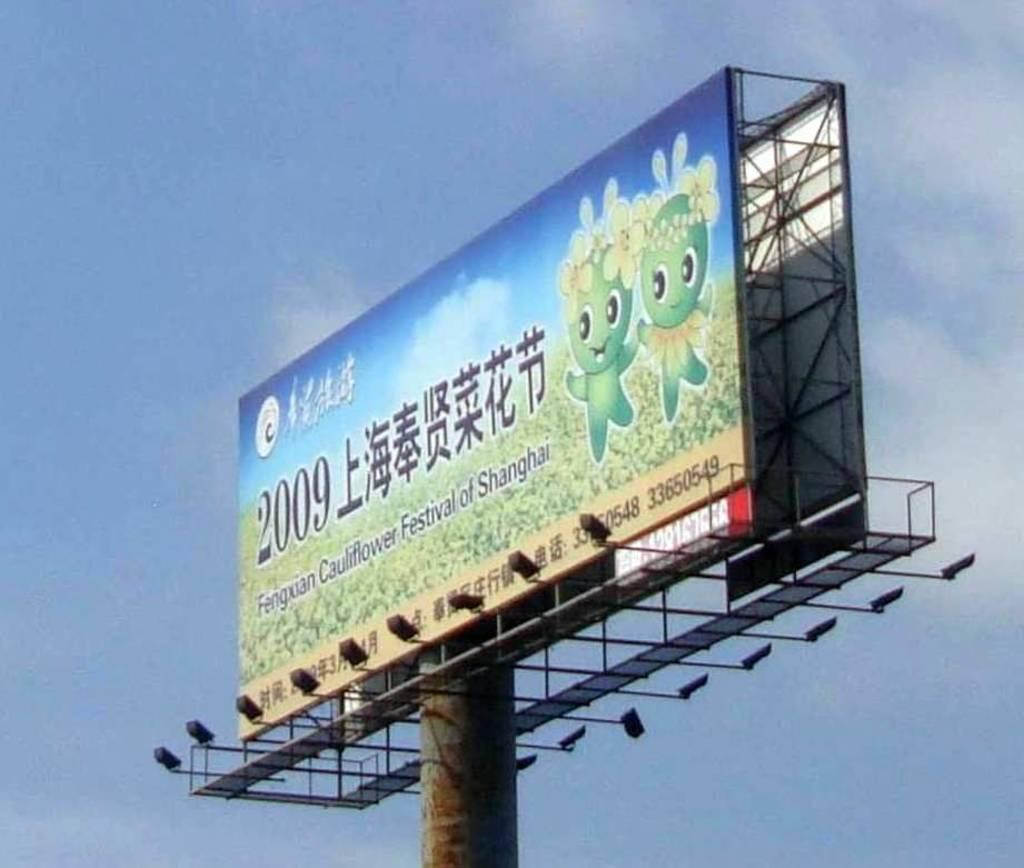<image>
Provide a brief description of the given image. The annual Cauliflower Festival takes place in Shanghai. 